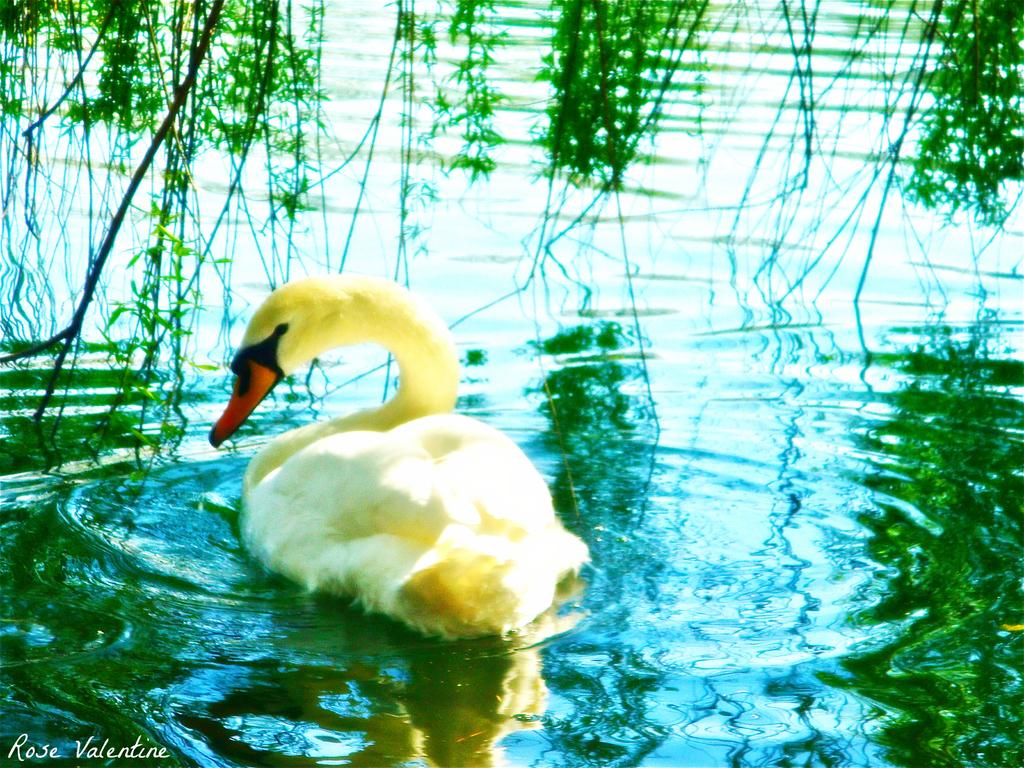What type of animal is in the image? There is a yellow duck in the image. Where is the duck located? The duck is in the water. What type of water body is the duck in? The water is in a pond. What type of vegetation can be seen in the image? There are green plants in the image. What type of cord is being used to play with the duck in the image? There is no cord present in the image, and the duck is not being played with. 